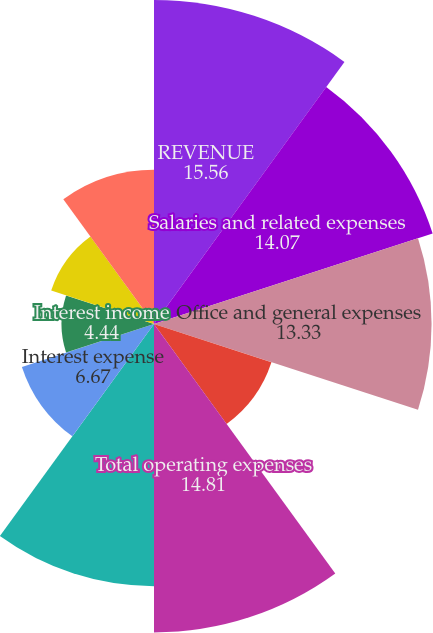Convert chart. <chart><loc_0><loc_0><loc_500><loc_500><pie_chart><fcel>REVENUE<fcel>Salaries and related expenses<fcel>Office and general expenses<fcel>Restructuring and other<fcel>Total operating expenses<fcel>OPERATING INCOME<fcel>Interest expense<fcel>Interest income<fcel>Other (expense) income net<fcel>Total (expenses) and other<nl><fcel>15.56%<fcel>14.07%<fcel>13.33%<fcel>5.93%<fcel>14.81%<fcel>12.59%<fcel>6.67%<fcel>4.44%<fcel>5.19%<fcel>7.41%<nl></chart> 